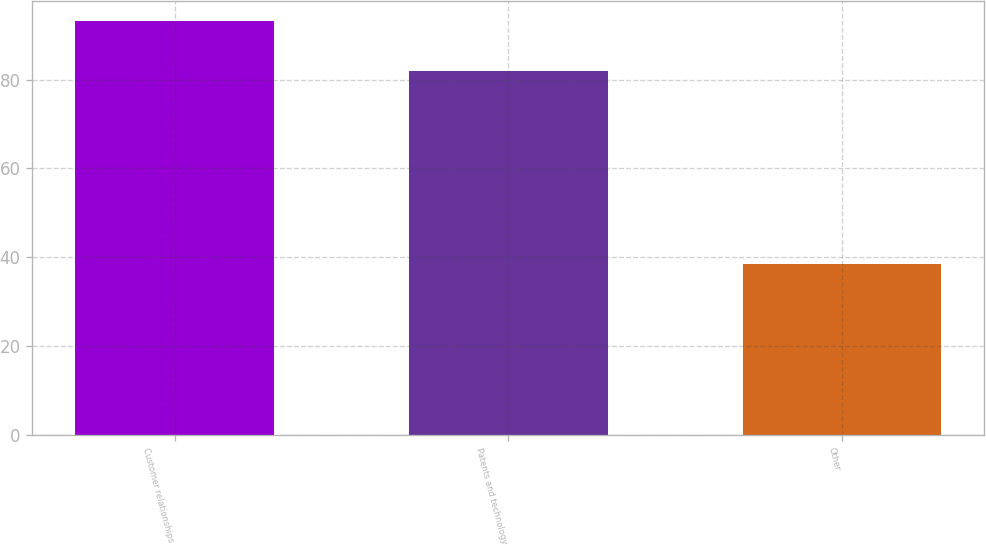<chart> <loc_0><loc_0><loc_500><loc_500><bar_chart><fcel>Customer relationships<fcel>Patents and technology<fcel>Other<nl><fcel>93.1<fcel>82<fcel>38.4<nl></chart> 